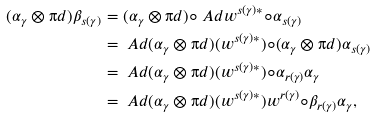<formula> <loc_0><loc_0><loc_500><loc_500>( \alpha _ { \gamma } \otimes \i d ) \beta _ { s ( \gamma ) } & = ( \alpha _ { \gamma } \otimes \i d ) \circ \ A d w ^ { s ( \gamma ) * } \circ \alpha _ { s ( \gamma ) } \\ & = \ A d ( \alpha _ { \gamma } \otimes \i d ) ( w ^ { s ( \gamma ) * } ) \circ ( \alpha _ { \gamma } \otimes \i d ) \alpha _ { s ( \gamma ) } \\ & = \ A d ( \alpha _ { \gamma } \otimes \i d ) ( w ^ { s ( \gamma ) * } ) \circ \alpha _ { r ( \gamma ) } \alpha _ { \gamma } \\ & = \ A d ( \alpha _ { \gamma } \otimes \i d ) ( w ^ { s ( \gamma ) * } ) w ^ { r ( \gamma ) } \circ \beta _ { r ( \gamma ) } \alpha _ { \gamma } ,</formula> 